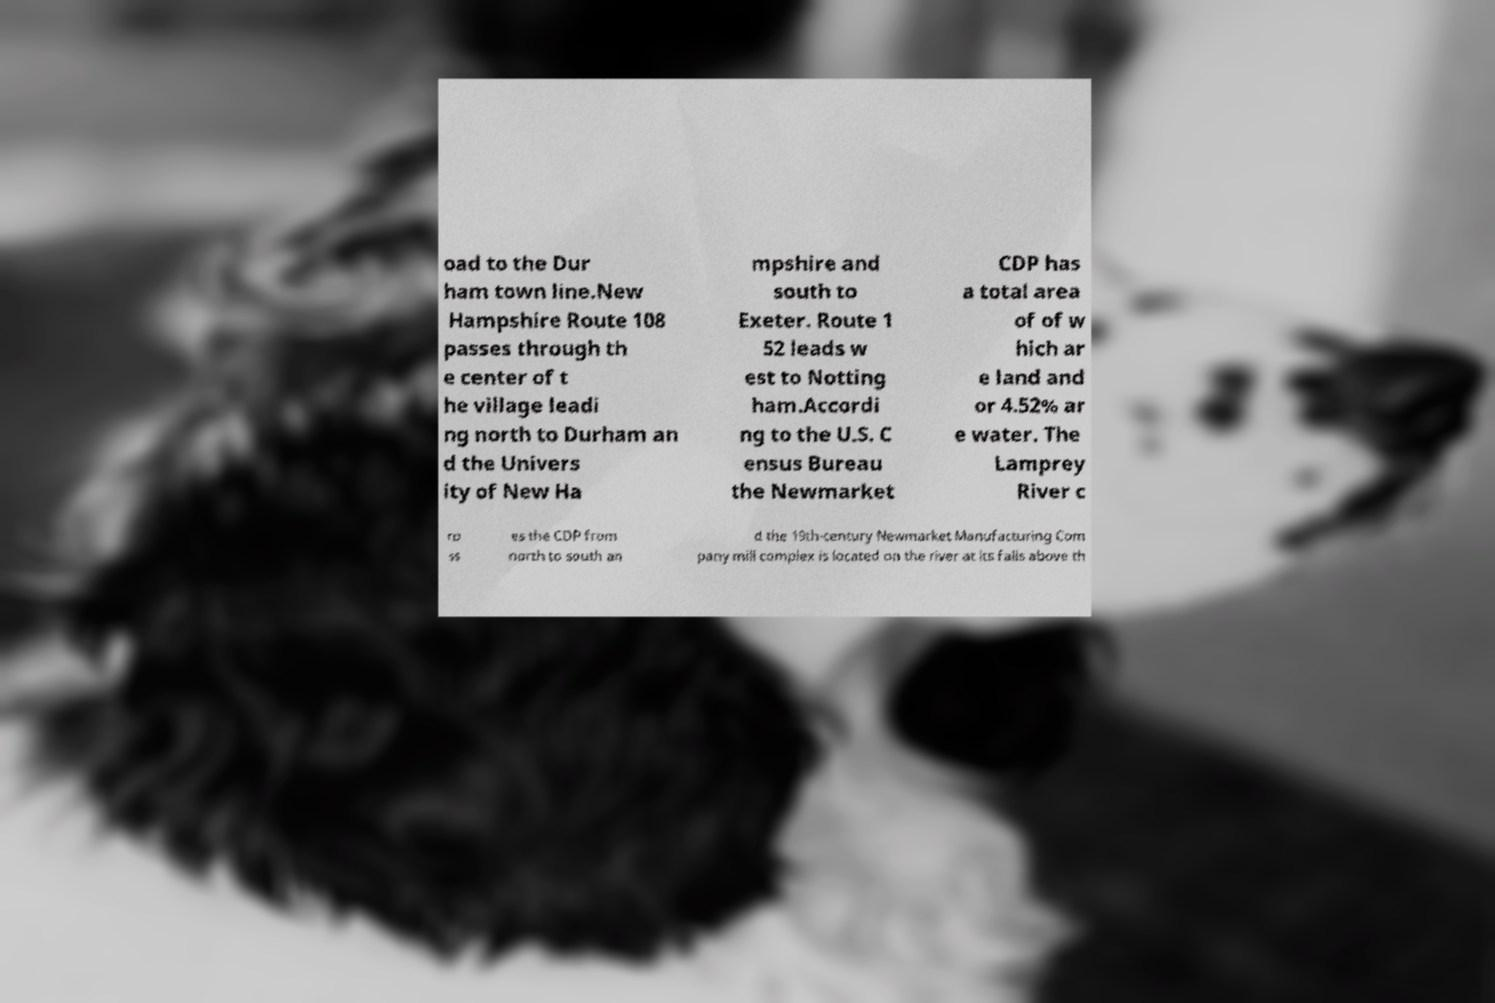Can you read and provide the text displayed in the image?This photo seems to have some interesting text. Can you extract and type it out for me? oad to the Dur ham town line.New Hampshire Route 108 passes through th e center of t he village leadi ng north to Durham an d the Univers ity of New Ha mpshire and south to Exeter. Route 1 52 leads w est to Notting ham.Accordi ng to the U.S. C ensus Bureau the Newmarket CDP has a total area of of w hich ar e land and or 4.52% ar e water. The Lamprey River c ro ss es the CDP from north to south an d the 19th-century Newmarket Manufacturing Com pany mill complex is located on the river at its falls above th 